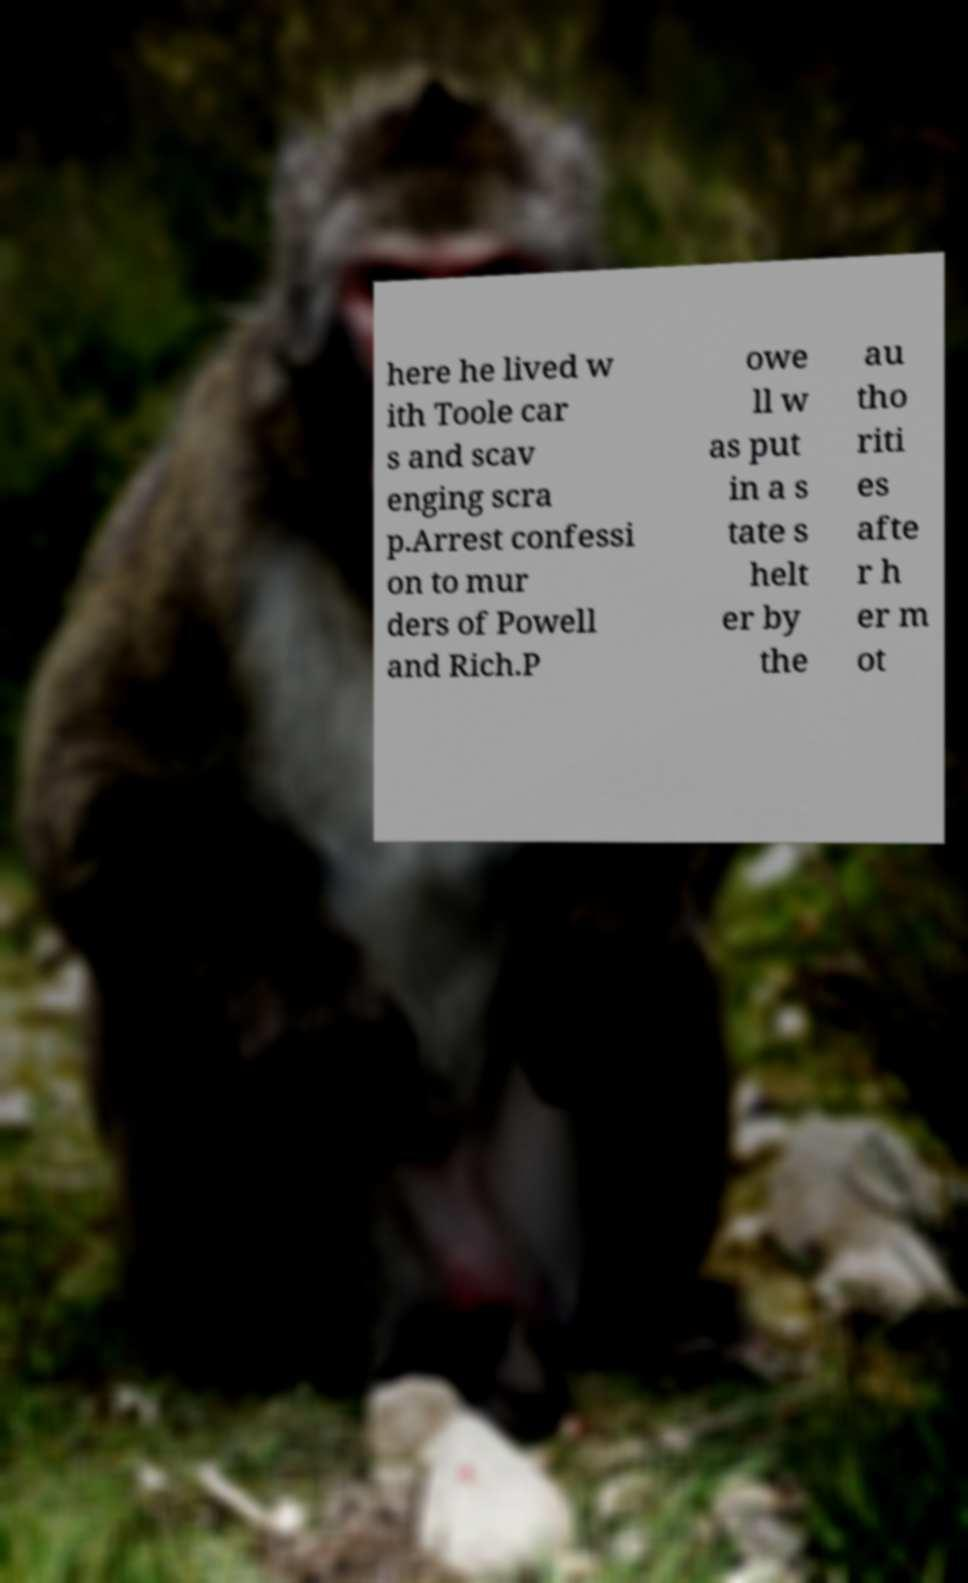Please identify and transcribe the text found in this image. here he lived w ith Toole car s and scav enging scra p.Arrest confessi on to mur ders of Powell and Rich.P owe ll w as put in a s tate s helt er by the au tho riti es afte r h er m ot 